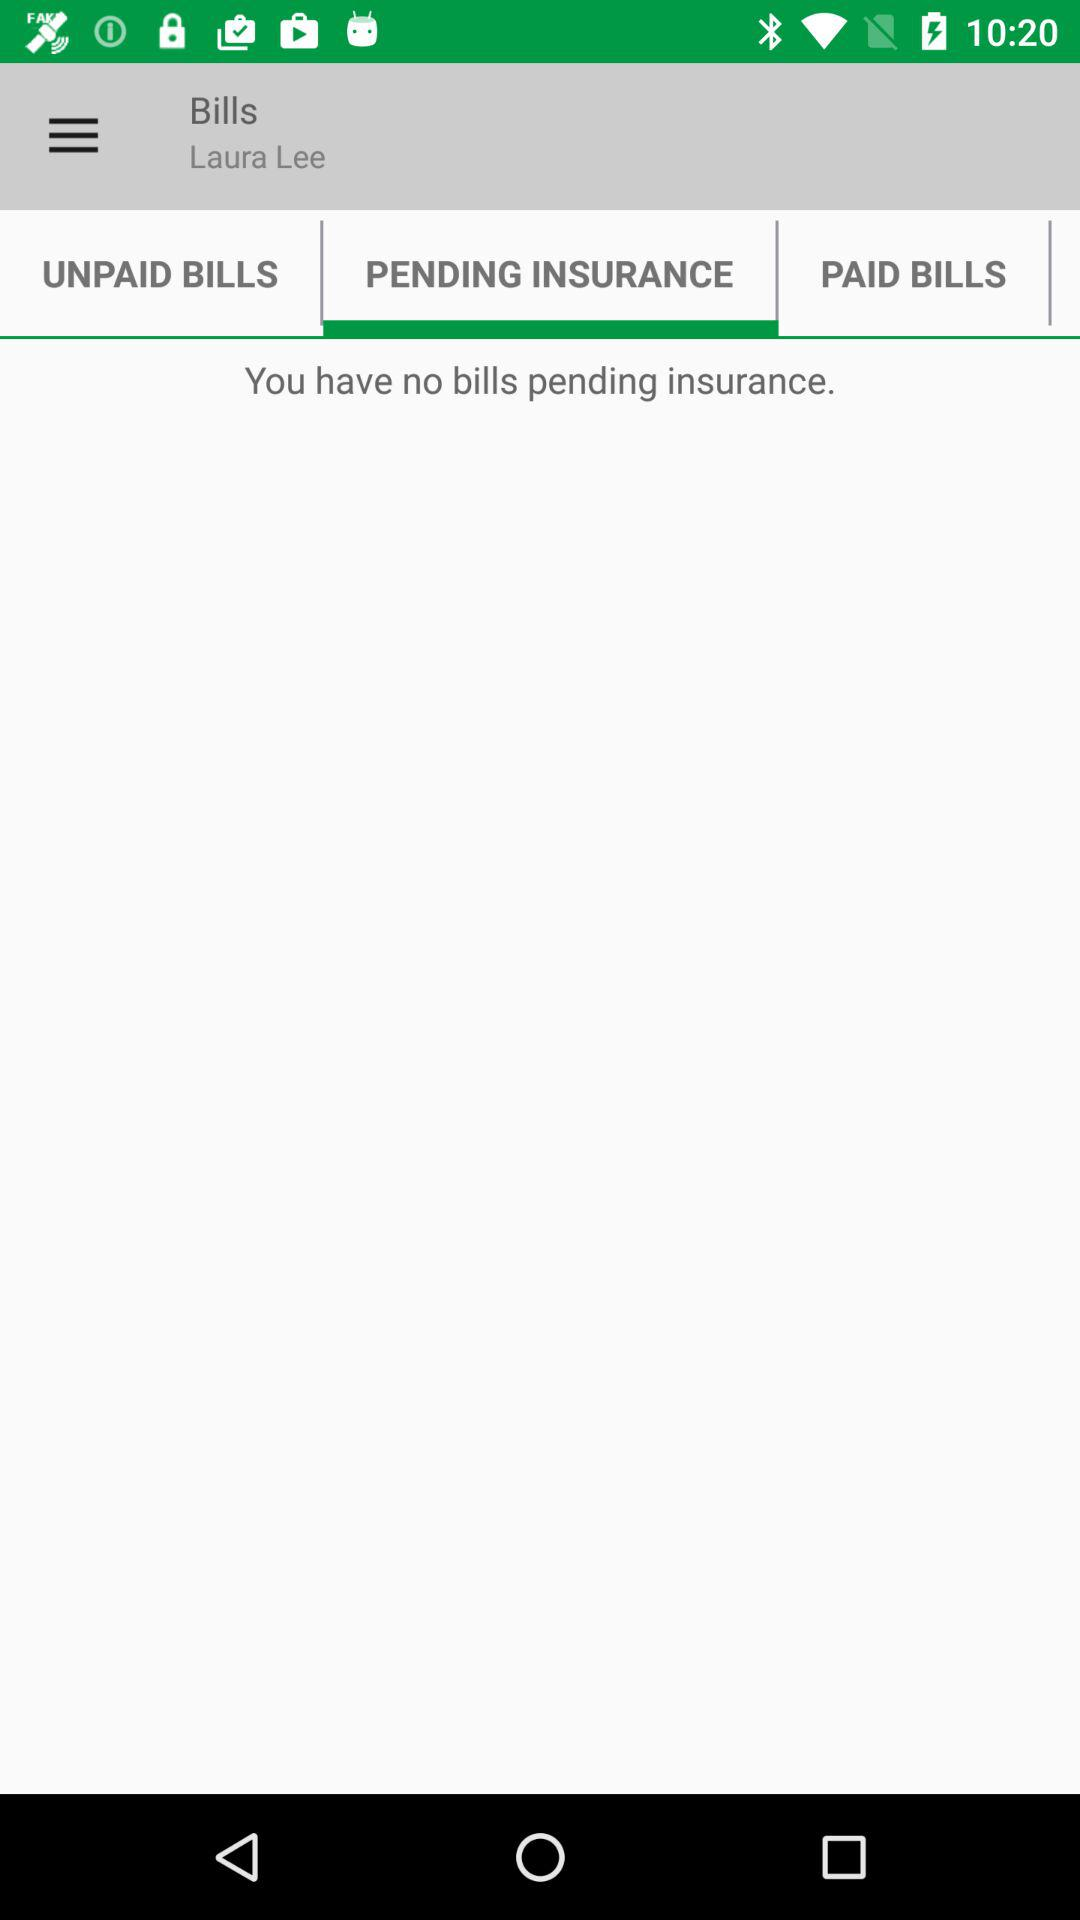Which tab is currently selected? The selected tab is pending insurance. 